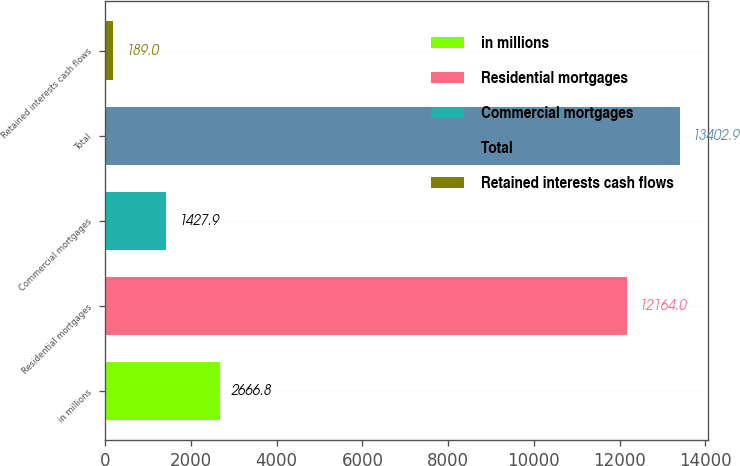Convert chart. <chart><loc_0><loc_0><loc_500><loc_500><bar_chart><fcel>in millions<fcel>Residential mortgages<fcel>Commercial mortgages<fcel>Total<fcel>Retained interests cash flows<nl><fcel>2666.8<fcel>12164<fcel>1427.9<fcel>13402.9<fcel>189<nl></chart> 